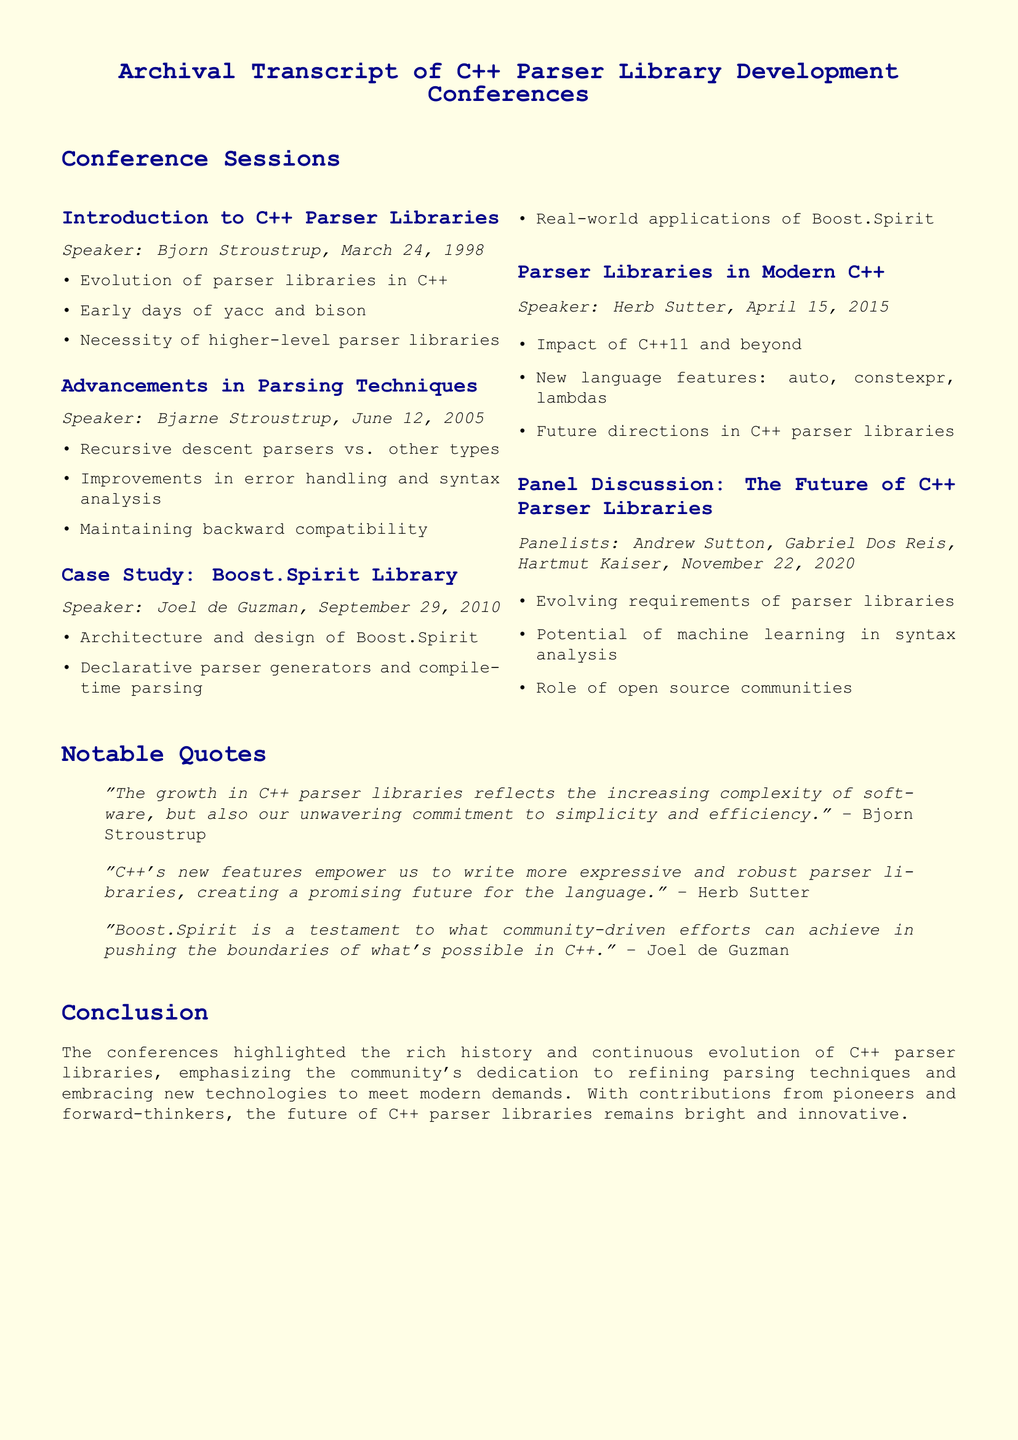what is the title of the first session? The title of the first session is on the topic of introductory perspectives on C++ parser libraries.
Answer: Introduction to C++ Parser Libraries who was the speaker for the case study on Boost.Spirit Library? The document specifies that Joel de Guzman was the speaker for this session.
Answer: Joel de Guzman what date did the panel discussion take place? The date of the panel discussion is explicitly mentioned in the document.
Answer: November 22, 2020 how many speakers are mentioned in the document? The total number of speakers can be counted from the sessions listed in the transcript.
Answer: Five speakers what is the main focus of Herb Sutter's session? The focus of Herb Sutter's session relates to changes in modern C++ and its implications for parser libraries.
Answer: Impact of C++11 and beyond who said "Boost.Spirit is a testament to what community-driven efforts can achieve"? The individual who made this statement is explicitly named in the notable quotes section of the document.
Answer: Joel de Guzman what are the main advancements discussed in Bjarne Stroustrup's session? The advancements covered in his session include parsing techniques, error handling, and backward compatibility.
Answer: Improvements in error handling and syntax analysis what does the conclusion emphasize about the future of C++ parser libraries? The conclusion reiterates the ongoing commitment of the community to innovation in parser libraries.
Answer: Community's dedication to refining parsing techniques 